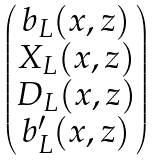Convert formula to latex. <formula><loc_0><loc_0><loc_500><loc_500>\begin{pmatrix} b _ { L } ( x , z ) \\ X _ { L } ( x , z ) \\ D _ { L } ( x , z ) \\ b ^ { \prime } _ { L } ( x , z ) \end{pmatrix}</formula> 